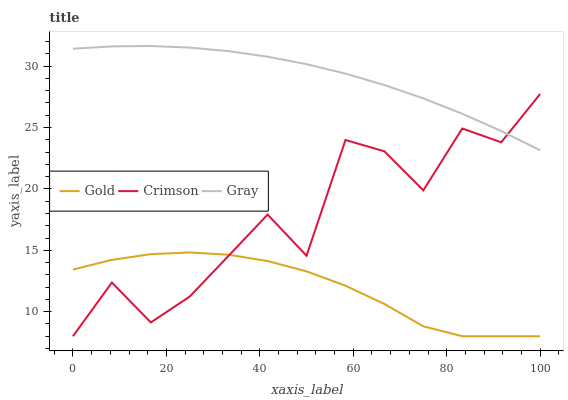Does Gold have the minimum area under the curve?
Answer yes or no. Yes. Does Gray have the maximum area under the curve?
Answer yes or no. Yes. Does Gray have the minimum area under the curve?
Answer yes or no. No. Does Gold have the maximum area under the curve?
Answer yes or no. No. Is Gray the smoothest?
Answer yes or no. Yes. Is Crimson the roughest?
Answer yes or no. Yes. Is Gold the smoothest?
Answer yes or no. No. Is Gold the roughest?
Answer yes or no. No. Does Gray have the lowest value?
Answer yes or no. No. Does Gray have the highest value?
Answer yes or no. Yes. Does Gold have the highest value?
Answer yes or no. No. Is Gold less than Gray?
Answer yes or no. Yes. Is Gray greater than Gold?
Answer yes or no. Yes. Does Gold intersect Gray?
Answer yes or no. No. 